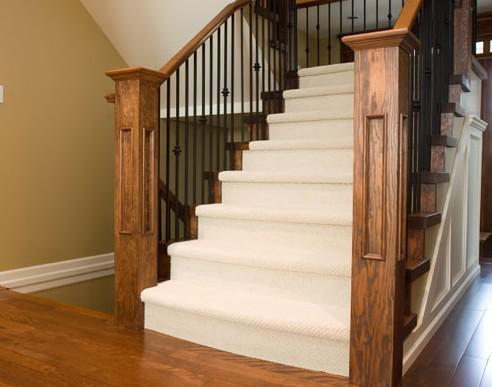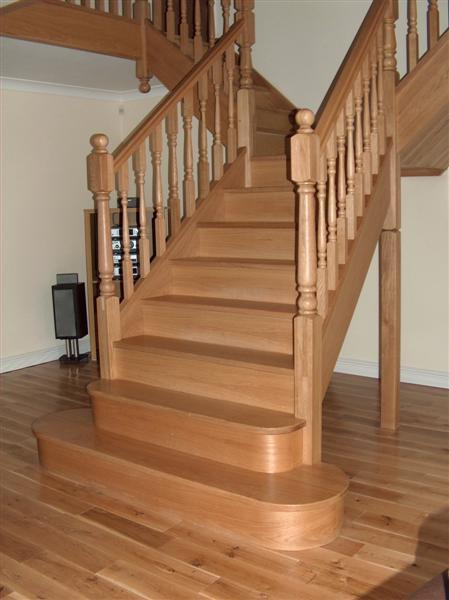The first image is the image on the left, the second image is the image on the right. Given the left and right images, does the statement "In at least one image there are white stair covered with brown wood top next to a black metal ball railing." hold true? Answer yes or no. No. 